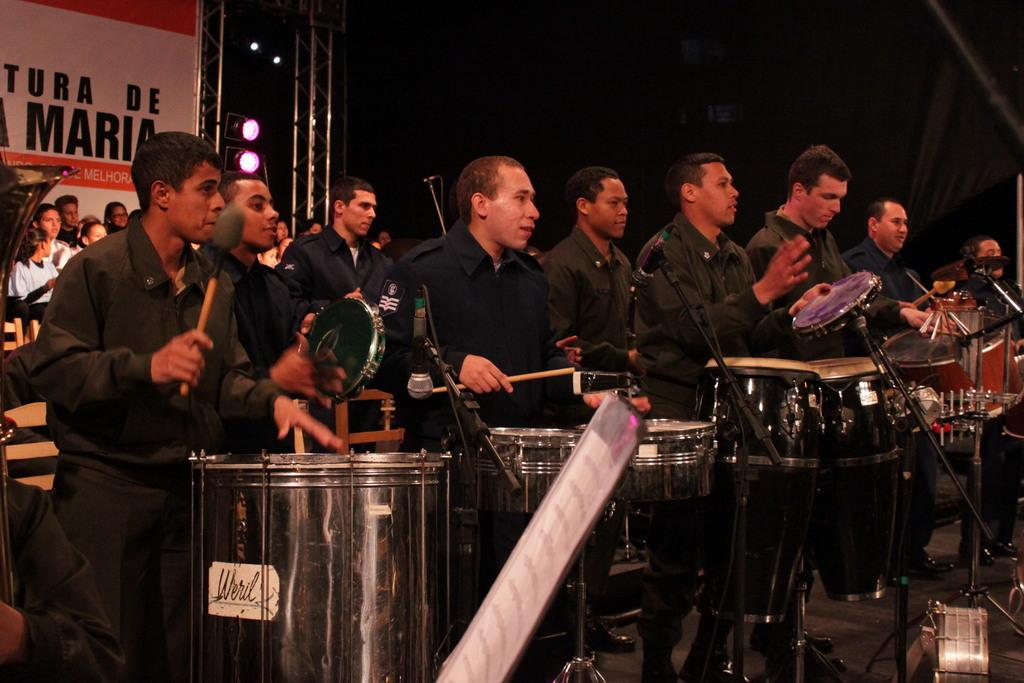What are the people in the image doing? There is a group of people playing drums in the image. Are there any other people in the image besides the drum players? Yes, there is a group of people sitting and enjoying behind the drum players. What type of stone can be seen in the image? There is no stone present in the image; it features a group of people playing drums and another group sitting and enjoying the performance. 